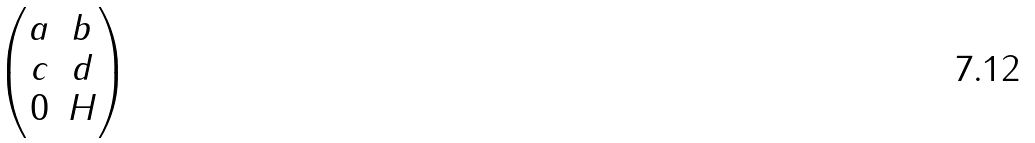Convert formula to latex. <formula><loc_0><loc_0><loc_500><loc_500>\begin{pmatrix} a & b \\ c & d \\ 0 & H \end{pmatrix}</formula> 